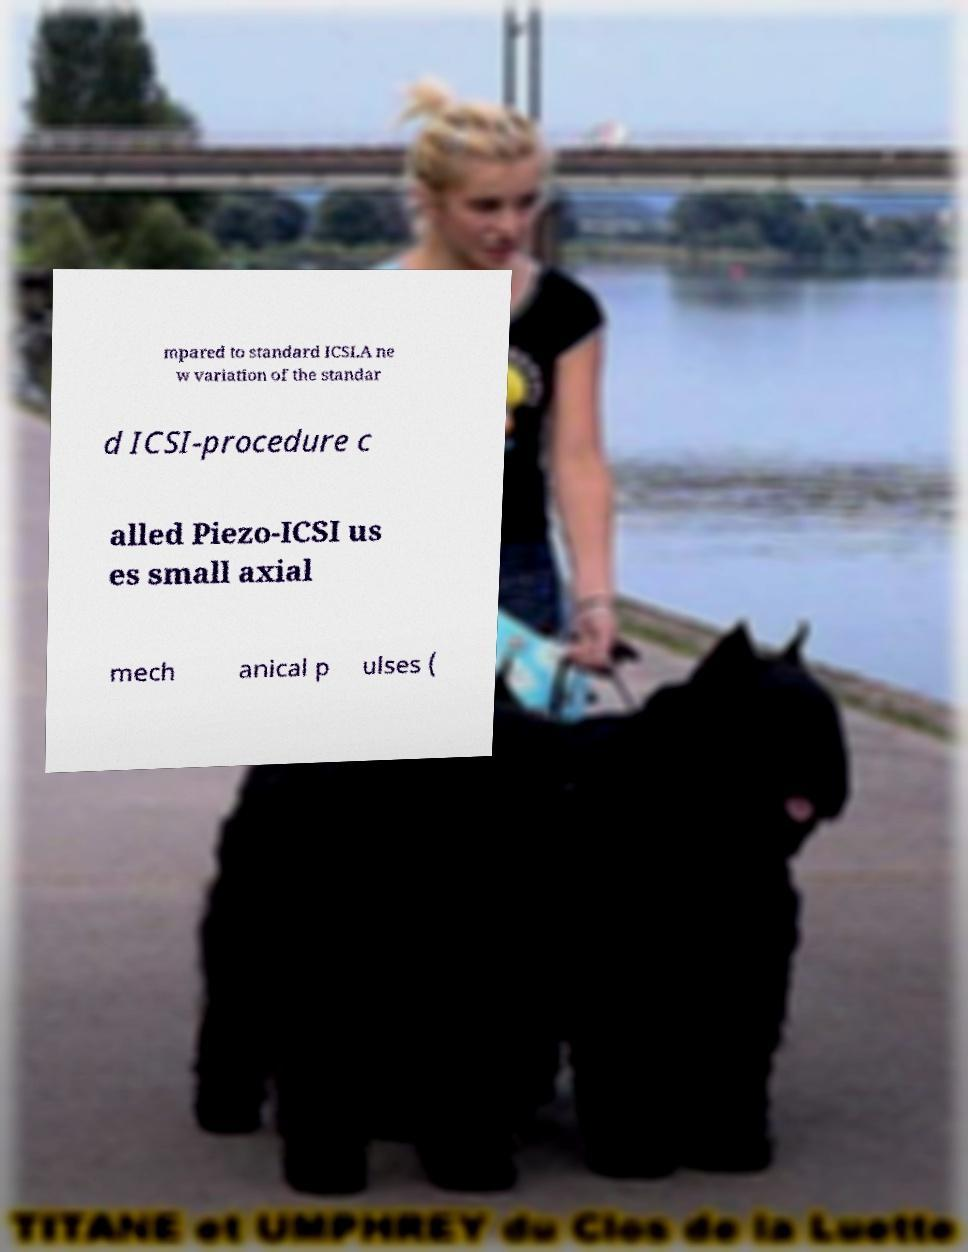Could you assist in decoding the text presented in this image and type it out clearly? mpared to standard ICSI.A ne w variation of the standar d ICSI-procedure c alled Piezo-ICSI us es small axial mech anical p ulses ( 